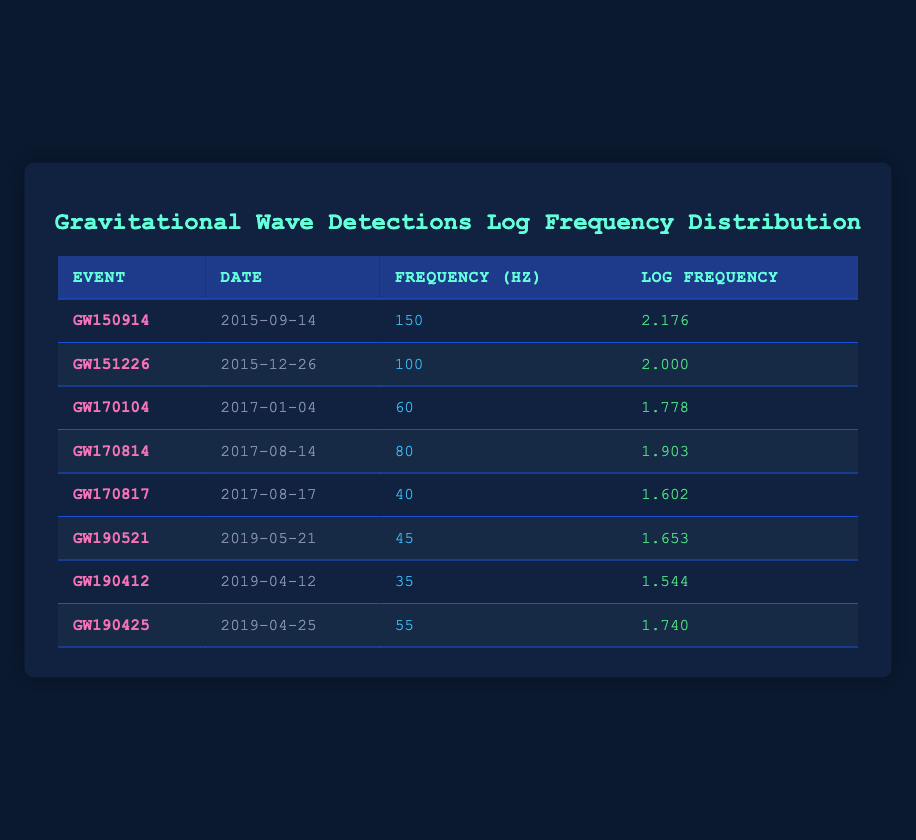What is the frequency of the event GW150914? The frequency for GW150914 is listed in the table under the "Frequency (Hz)" column, which shows a value of 150 Hz.
Answer: 150 Hz Which event had the highest log frequency? By comparing the values in the "Log Frequency" column, GW150914 has the highest log frequency at 2.176.
Answer: GW150914 What is the average frequency of detection events in 2017? The frequency values for events in 2017 are 60 (GW170104), 80 (GW170814), and 40 (GW170817). The sum is 60 + 80 + 40 = 180, and there are 3 events, so the average is 180/3 = 60 Hz.
Answer: 60 Hz Is GW190425 the event with the lowest frequency? Examining the frequency values, GW190425 has a frequency of 55 Hz, which is higher than GW190412's 35 Hz. Therefore, GW190425 is not the lowest.
Answer: No What is the difference in log frequency between GW170814 and GW170817? The log frequency for GW170814 is 1.903 and for GW170817 is 1.602. To find the difference, we calculate 1.903 - 1.602 = 0.301.
Answer: 0.301 How many events have a frequency below 60 Hz? The events with frequencies below 60 Hz are GW170817 (40 Hz), GW190521 (45 Hz), and GW190412 (35 Hz). This totals 3 events.
Answer: 3 events Which is the most recent event listed in the table? The dates of the events are listed, and the most recent date is 2019-05-21 for GW190521.
Answer: GW190521 What is the sum of frequencies for all events listed? Adding all the frequency values: 150 + 100 + 60 + 80 + 40 + 45 + 35 + 55 = 565 Hz.
Answer: 565 Hz 